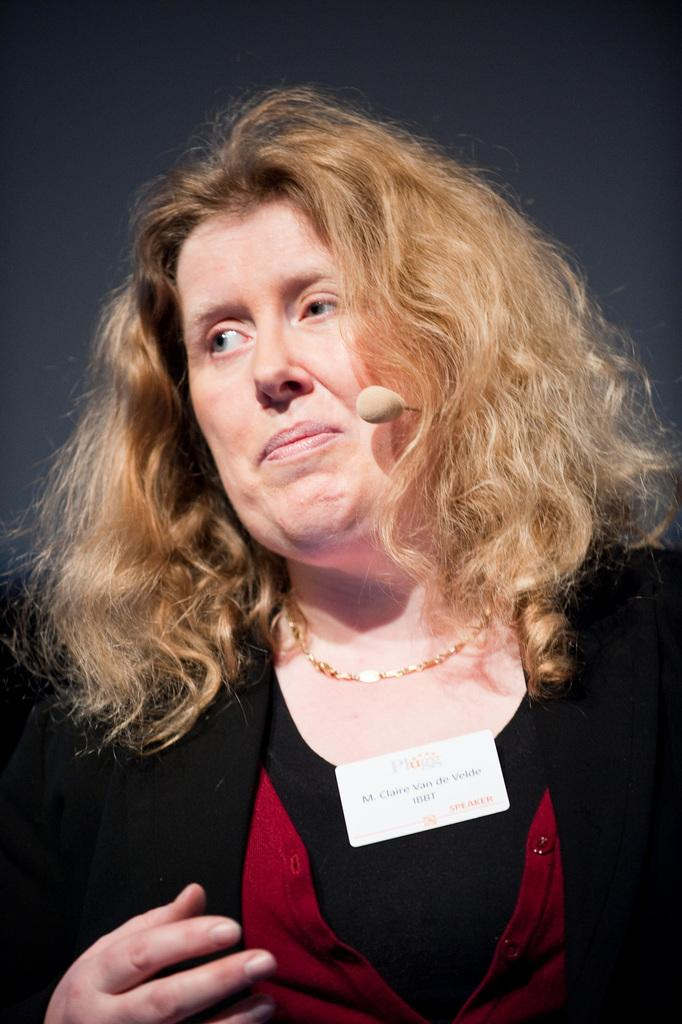Who is the main subject in the image? There is a woman in the image. What is the woman holding in the image? The woman is holding a mic. What can be said about the woman's hair color? The woman's hair color is gold. Who else is present in the image? There is a girl in the image. What is the girl wearing? The girl is wearing a black dress. Can you describe any additional details about the girl's attire? The girl has a badge on her dress. What type of bear can be seen in the image? There is no bear present in the image. Is the moon visible in the image? The moon is not visible in the image. 